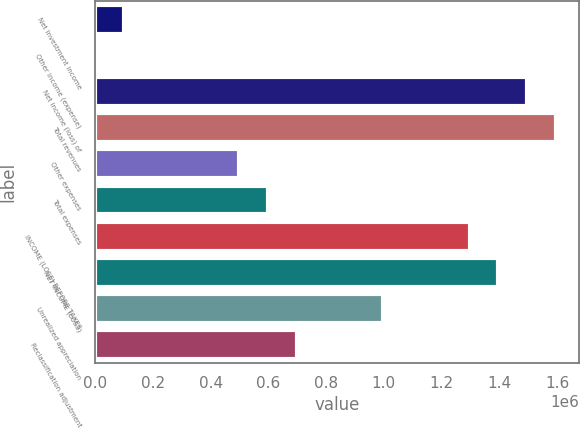Convert chart to OTSL. <chart><loc_0><loc_0><loc_500><loc_500><bar_chart><fcel>Net investment income<fcel>Other income (expense)<fcel>Net income (loss) of<fcel>Total revenues<fcel>Other expenses<fcel>Total expenses<fcel>INCOME (LOSS) BEFORE TAXES<fcel>NET INCOME (LOSS)<fcel>Unrealized appreciation<fcel>Reclassification adjustment<nl><fcel>100224<fcel>459<fcel>1.49693e+06<fcel>1.5967e+06<fcel>499284<fcel>599049<fcel>1.2974e+06<fcel>1.39717e+06<fcel>998109<fcel>698814<nl></chart> 